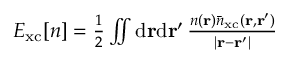Convert formula to latex. <formula><loc_0><loc_0><loc_500><loc_500>\begin{array} { r } { E _ { x c } { [ n ] } = \frac { 1 } { 2 } \iint d { r } d { r } ^ { \prime } \, \frac { n ( { r } ) \bar { n } _ { x c } ( { r } , { r } ^ { \prime } ) } { | { r } - { r } ^ { \prime } | } } \end{array}</formula> 